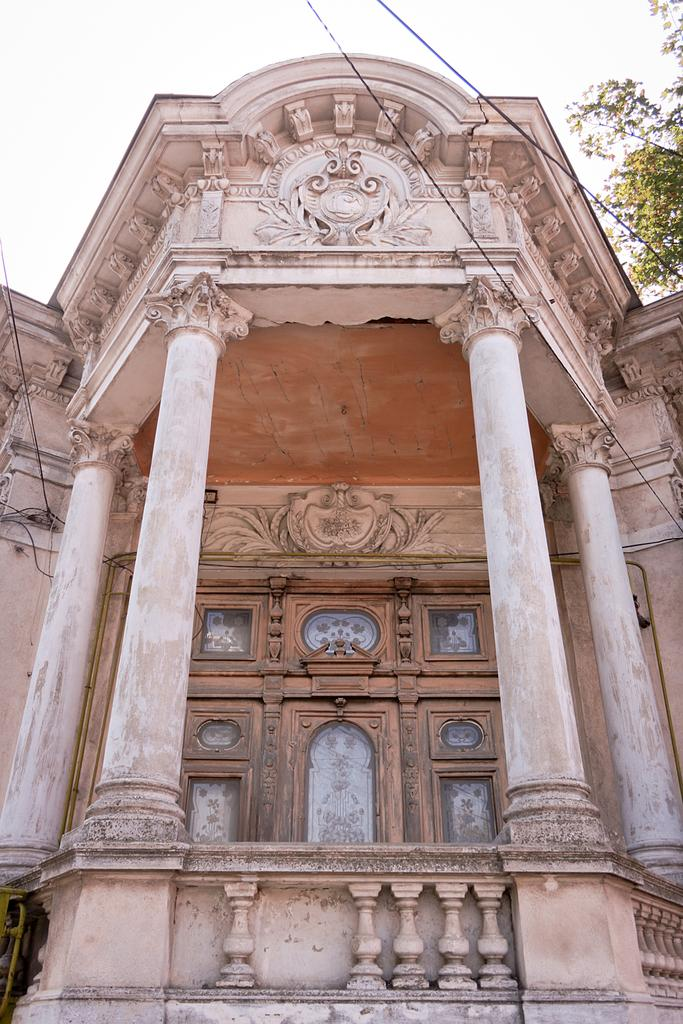What type of structure is in the picture? There is a building in the picture. What architectural features can be seen on the building? The building has pillars. What material is used for the door of the building? The building has a wooden door. What natural element is present in the top right side of the picture? There is a tree on the top right side of the picture. How many people are standing next to the grain in the picture? There is no grain present in the picture, and therefore no people standing next to it. 